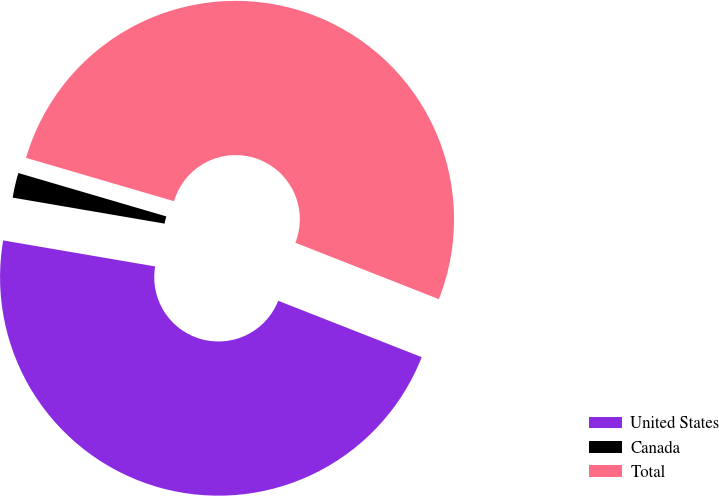Convert chart to OTSL. <chart><loc_0><loc_0><loc_500><loc_500><pie_chart><fcel>United States<fcel>Canada<fcel>Total<nl><fcel>46.74%<fcel>1.84%<fcel>51.42%<nl></chart> 